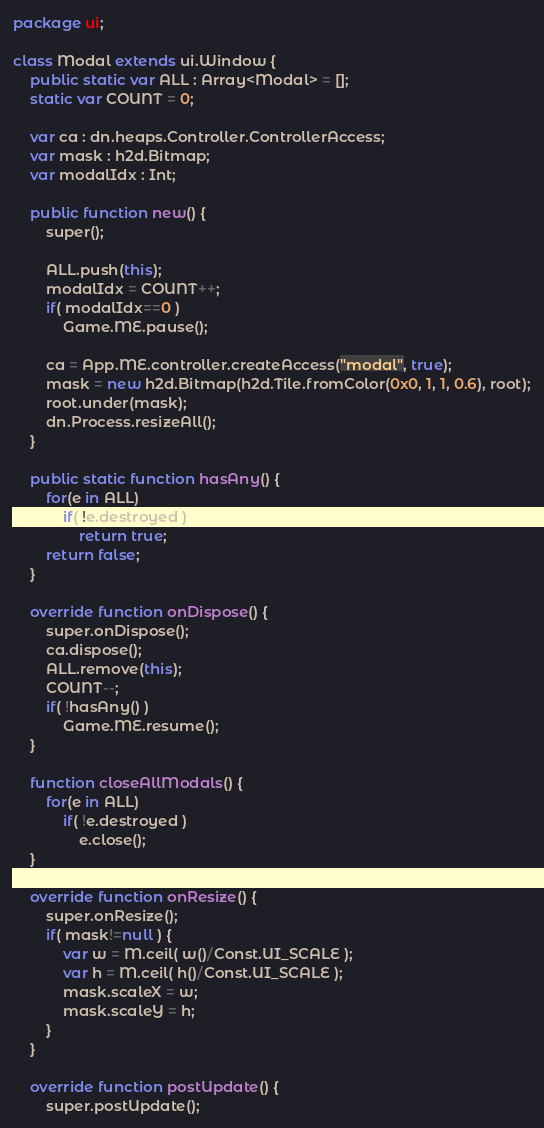<code> <loc_0><loc_0><loc_500><loc_500><_Haxe_>package ui;

class Modal extends ui.Window {
	public static var ALL : Array<Modal> = [];
	static var COUNT = 0;

	var ca : dn.heaps.Controller.ControllerAccess;
	var mask : h2d.Bitmap;
	var modalIdx : Int;

	public function new() {
		super();

		ALL.push(this);
		modalIdx = COUNT++;
		if( modalIdx==0 )
			Game.ME.pause();

		ca = App.ME.controller.createAccess("modal", true);
		mask = new h2d.Bitmap(h2d.Tile.fromColor(0x0, 1, 1, 0.6), root);
		root.under(mask);
		dn.Process.resizeAll();
	}

	public static function hasAny() {
		for(e in ALL)
			if( !e.destroyed )
				return true;
		return false;
	}

	override function onDispose() {
		super.onDispose();
		ca.dispose();
		ALL.remove(this);
		COUNT--;
		if( !hasAny() )
			Game.ME.resume();
	}

	function closeAllModals() {
		for(e in ALL)
			if( !e.destroyed )
				e.close();
	}

	override function onResize() {
		super.onResize();
		if( mask!=null ) {
			var w = M.ceil( w()/Const.UI_SCALE );
			var h = M.ceil( h()/Const.UI_SCALE );
			mask.scaleX = w;
			mask.scaleY = h;
		}
	}

	override function postUpdate() {
		super.postUpdate();</code> 